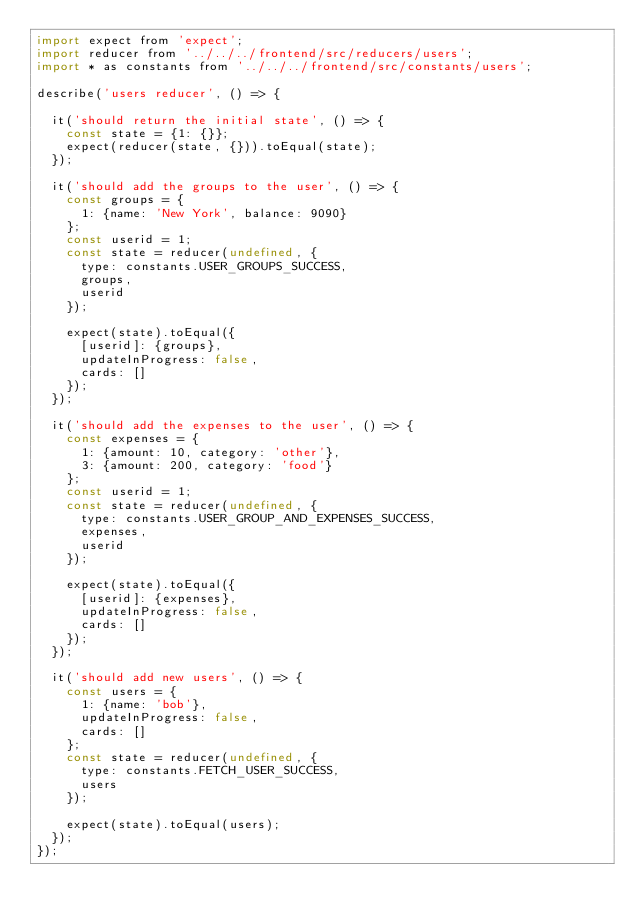Convert code to text. <code><loc_0><loc_0><loc_500><loc_500><_JavaScript_>import expect from 'expect';
import reducer from '../../../frontend/src/reducers/users';
import * as constants from '../../../frontend/src/constants/users';

describe('users reducer', () => {

  it('should return the initial state', () => {
    const state = {1: {}};
    expect(reducer(state, {})).toEqual(state);
  });

  it('should add the groups to the user', () => {
    const groups = {
      1: {name: 'New York', balance: 9090}
    };
    const userid = 1;
    const state = reducer(undefined, {
      type: constants.USER_GROUPS_SUCCESS,
      groups,
      userid
    });

    expect(state).toEqual({
      [userid]: {groups},
      updateInProgress: false,
      cards: []
    });
  });

  it('should add the expenses to the user', () => {
    const expenses = {
      1: {amount: 10, category: 'other'},
      3: {amount: 200, category: 'food'}
    };
    const userid = 1;
    const state = reducer(undefined, {
      type: constants.USER_GROUP_AND_EXPENSES_SUCCESS,
      expenses,
      userid
    });

    expect(state).toEqual({
      [userid]: {expenses},
      updateInProgress: false,
      cards: []
    });
  });

  it('should add new users', () => {
    const users = {
      1: {name: 'bob'},
      updateInProgress: false,
      cards: []
    };
    const state = reducer(undefined, {
      type: constants.FETCH_USER_SUCCESS,
      users
    });

    expect(state).toEqual(users);
  });
});
</code> 